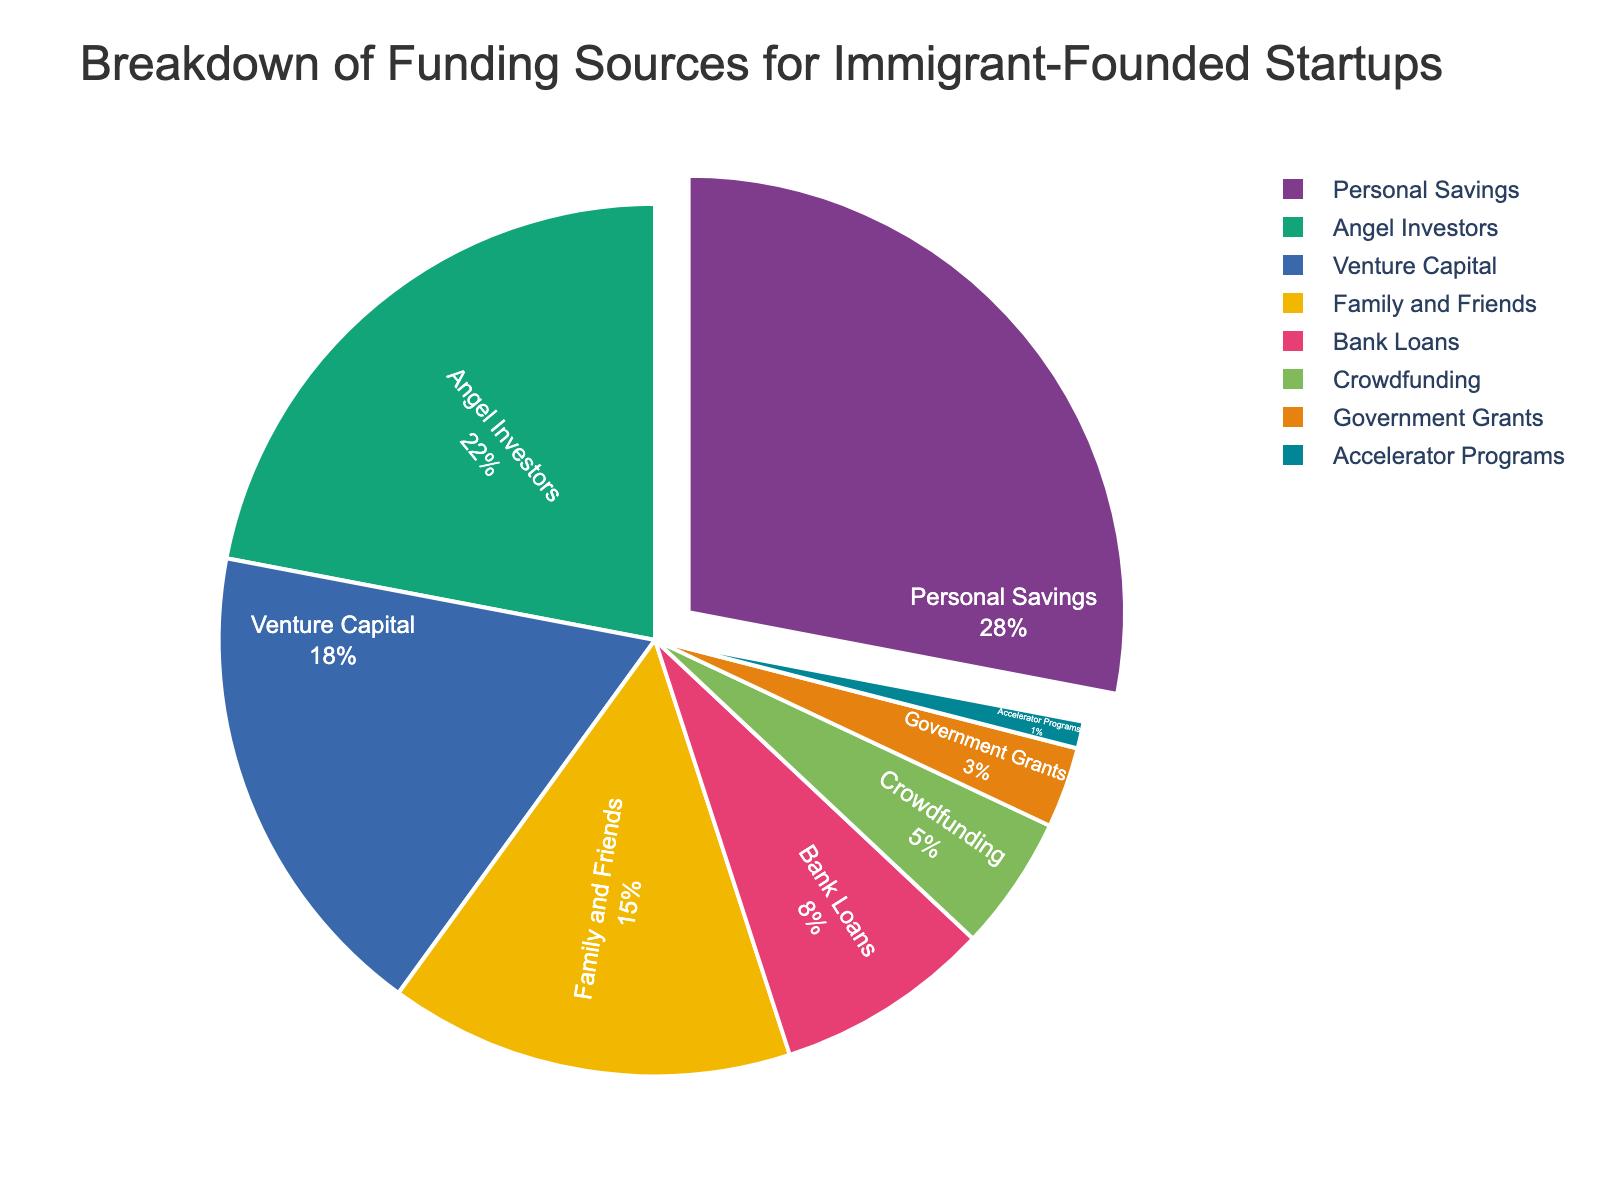What's the largest funding source for immigrant-founded startups? The largest section of the pie chart represents Personal Savings, which occupies the biggest visual space and has the highest percentage.
Answer: Personal Savings What's the percentage difference between Venture Capital and Bank Loans? Venture Capital has a percentage of 18% and Bank Loans have 8%. The difference is calculated as 18% - 8% = 10%.
Answer: 10% Which funding source is more prevalent, Angel Investors or Family and Friends? By comparing the percentages, Angel Investors have 22% while Family and Friends have 15%. Therefore, Angel Investors are more prevalent.
Answer: Angel Investors Are Government Grants or Crowdfunding utilized more as funding sources? By looking at the pie chart, Government Grants have 3% and Crowdfunding has 5%. Hence, Crowdfunding is utilized more.
Answer: Crowdfunding What is the combined percentage of Personal Savings and Venture Capital? Personal Savings is 28% and Venture Capital is 18%. Adding these together gives 28% + 18% = 46%.
Answer: 46% Which funding source occupies the smallest portion of the pie chart? The smallest section of the pie chart corresponds to Accelerator Programs, which has 1%.
Answer: Accelerator Programs Is the percentage of Bank Loans more or less than half the percentage of Angel Investors? Bank Loans have 8% and Angel Investors have 22%. Half of 22% is 11%. Since 8% is less than 11%, Bank Loans are less than half the percentage of Angel Investors.
Answer: Less How much more prevalent are Personal Savings compared to Family and Friends? Personal Savings stand at 28%, while Family and Friends have 15%. The difference is 28% - 15% = 13%.
Answer: 13% Compare the total percentage of funding from Personal Savings, Family and Friends, and Crowdfunding to 50%. Adding the percentages: 28% (Personal Savings) + 15% (Family and Friends) + 5% (Crowdfunding) = 48%. Therefore, the total is less than 50%.
Answer: Less than 50% How does the total percentage of Angel Investors and Venture Capital compare to the total percentage of the other funding sources combined? Angel Investors (22%) + Venture Capital (18%) = 40%. The remaining sources add up to 28% (Personal Savings) + 15% (Family and Friends) + 8% (Bank Loans) + 5% (Crowdfunding) + 3% (Government Grants) + 1% (Accelerator Programs) = 60%. Hence, the total percentage of other sources combined is more.
Answer: Other sources combined is more 